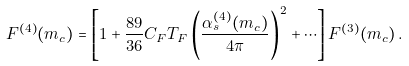<formula> <loc_0><loc_0><loc_500><loc_500>F ^ { ( 4 ) } ( m _ { c } ) = \left [ 1 + \frac { 8 9 } { 3 6 } C _ { F } T _ { F } \left ( \frac { \alpha _ { s } ^ { ( 4 ) } ( m _ { c } ) } { 4 \pi } \right ) ^ { 2 } + \cdots \right ] F ^ { ( 3 ) } ( m _ { c } ) \, .</formula> 